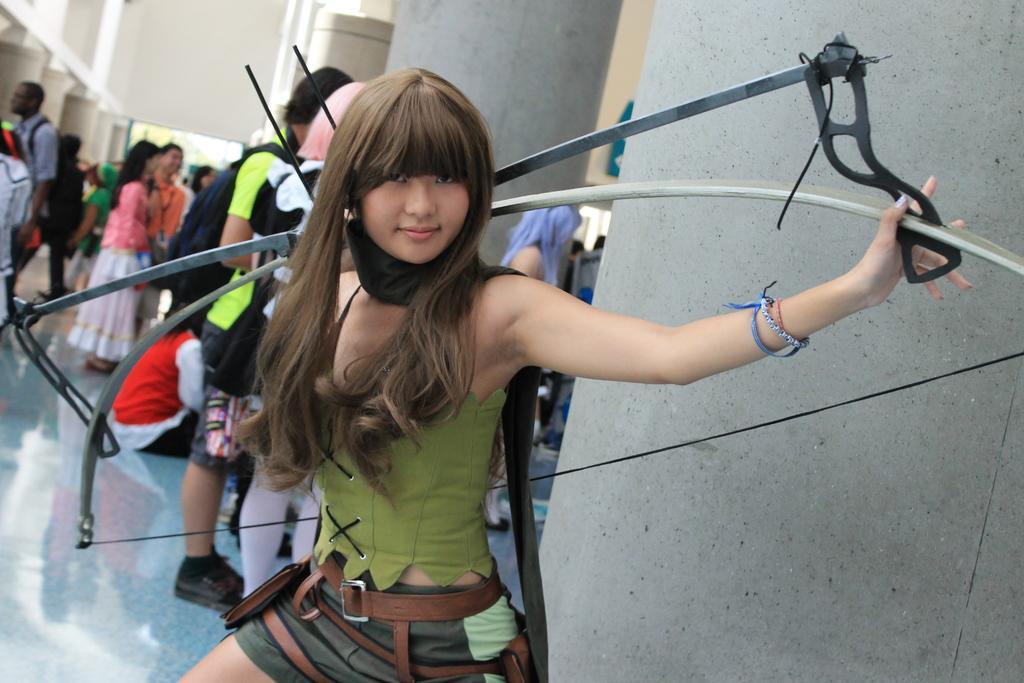How would you summarize this image in a sentence or two? In this picture i can see a woman holding a bow and there are men and women standing in the background. 